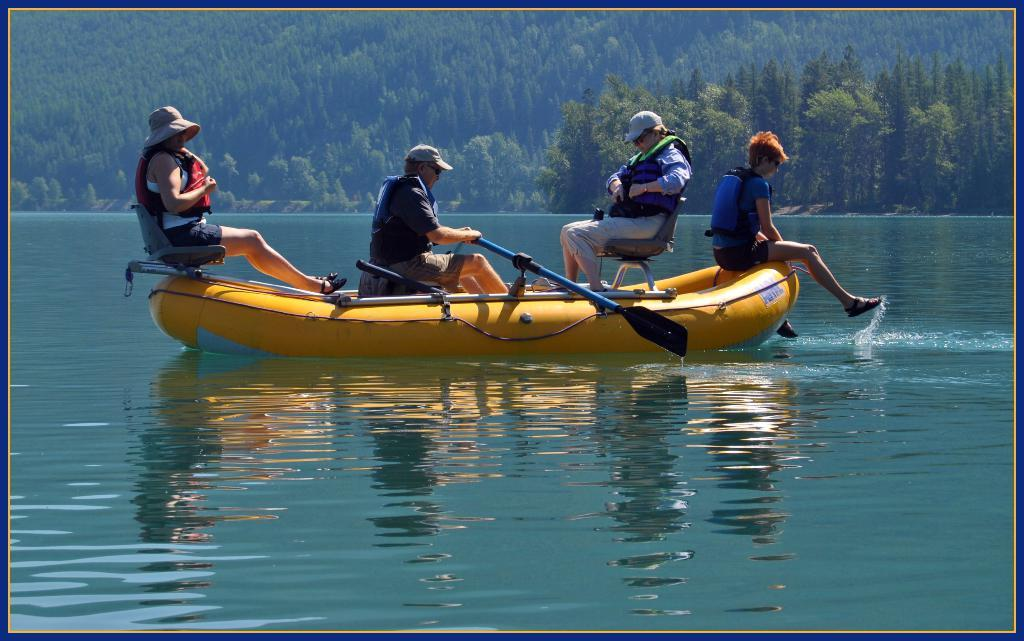How many people are on the boat in the image? There are four people sitting on the boat in the image. What can be seen in the background of the image? There are trees and plants in the background of the image. What type of water is visible in the image? The water visible in the image appears to be in a lake. Where is the picture of a boy in the image? There is no picture of a boy present in the image. How many cherries are on the boat in the image? There are no cherries visible in the image; it features a boat with four people on it. 